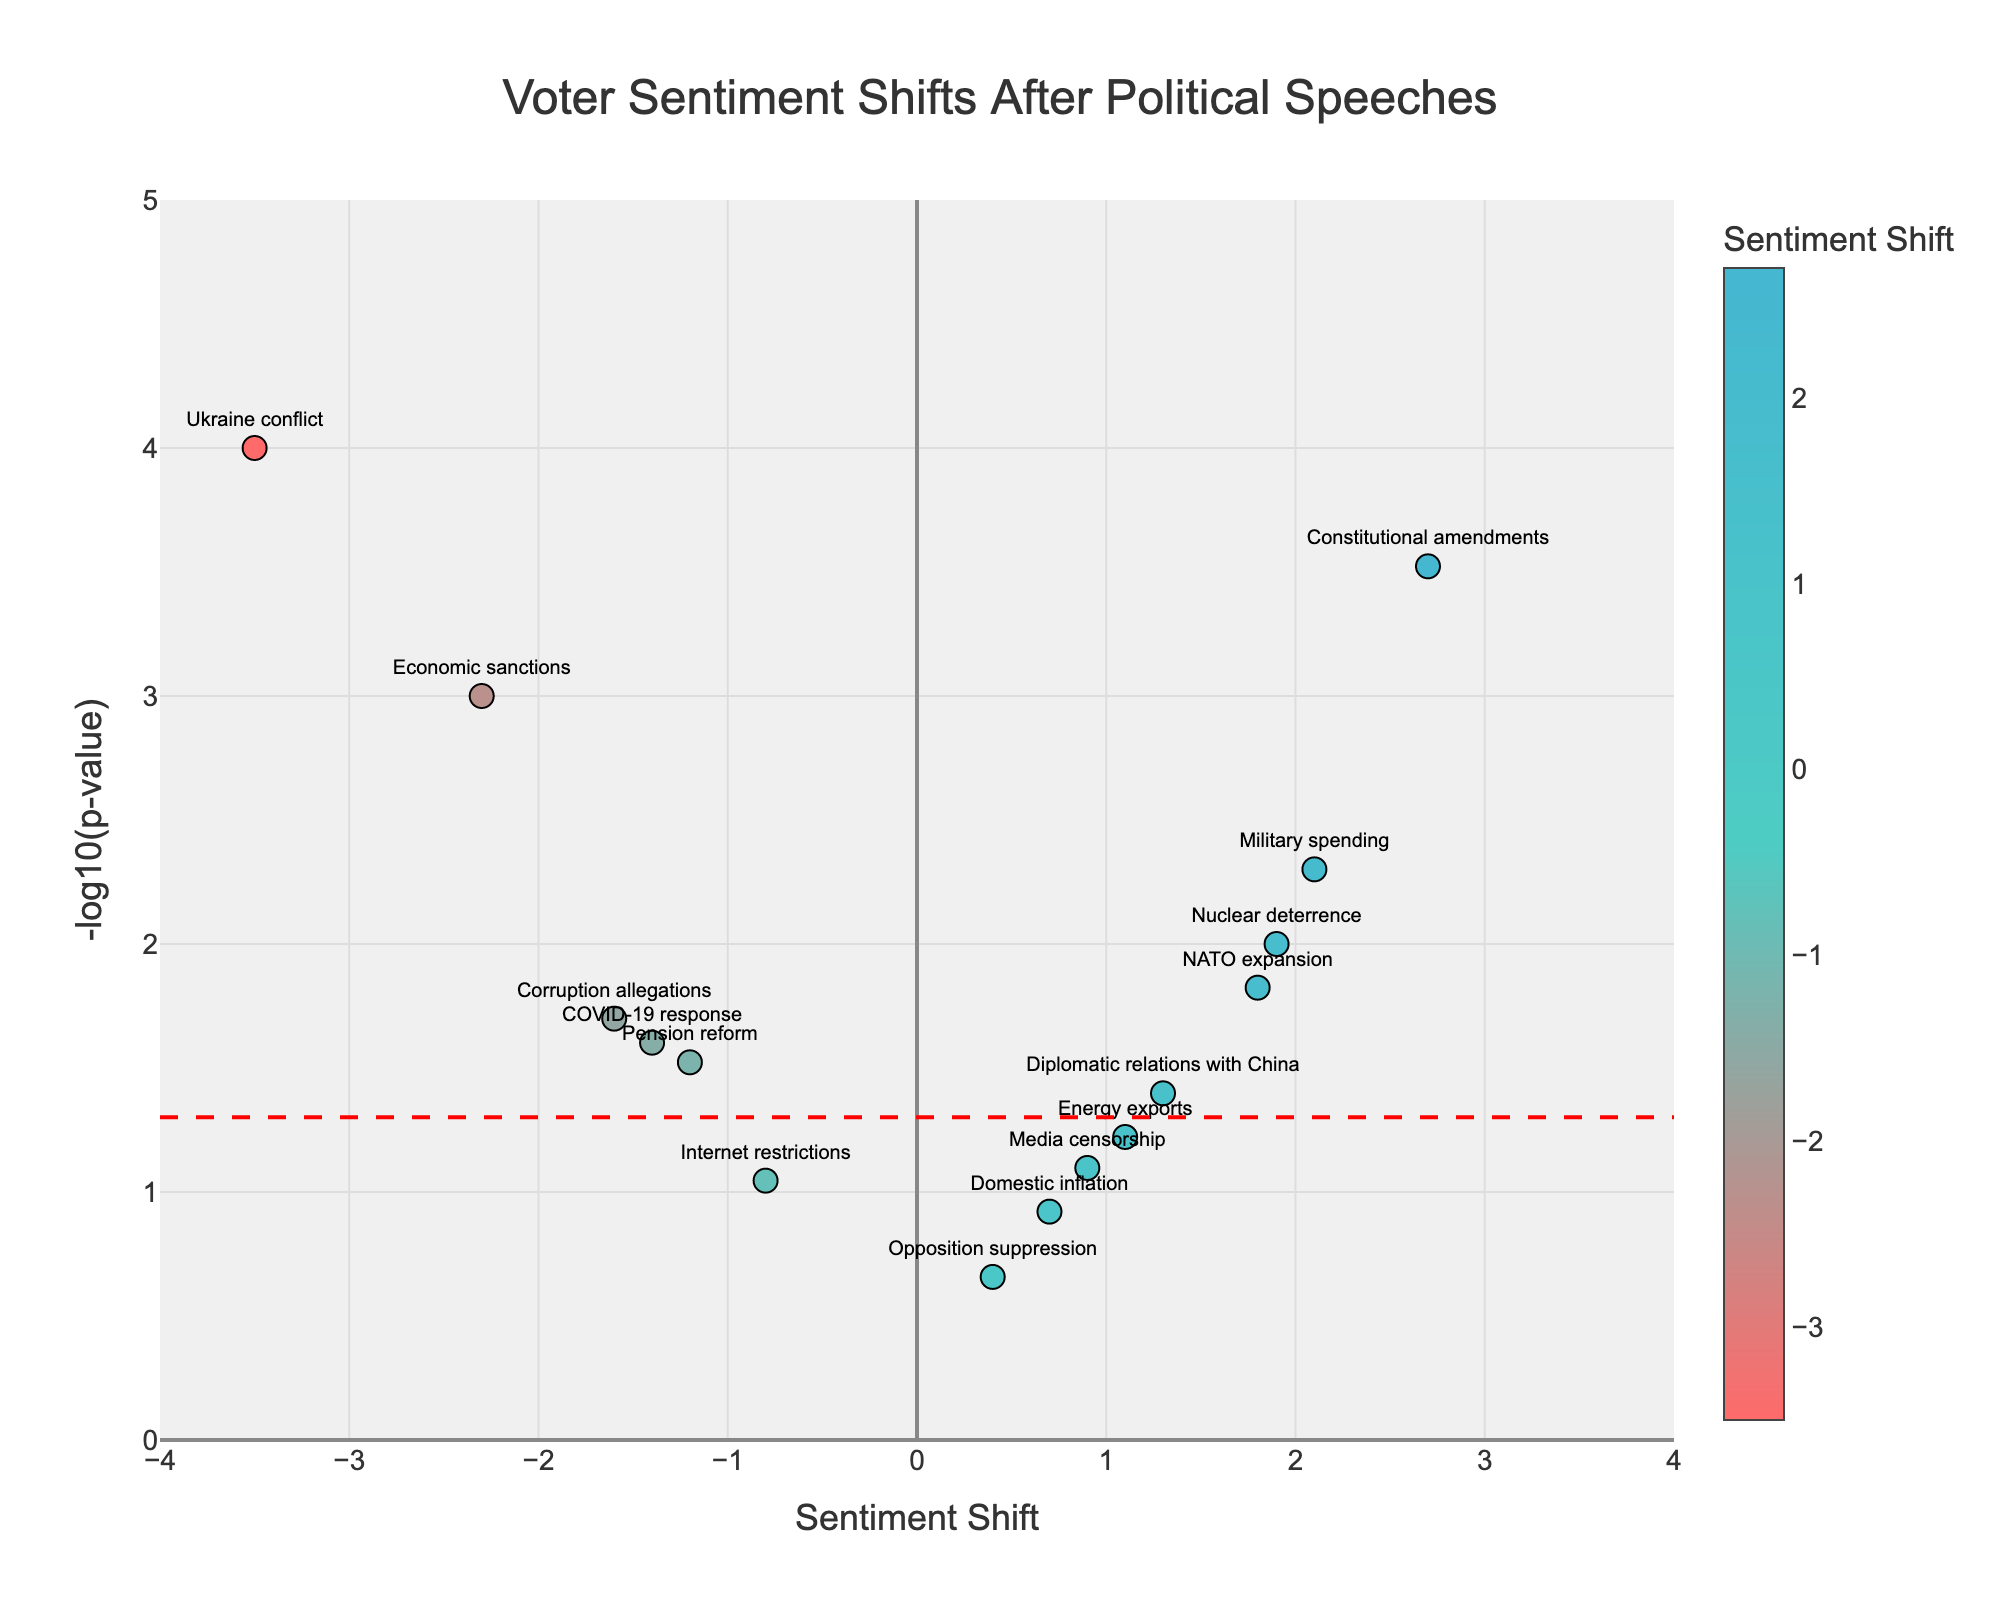How many policy issues showed a positive sentiment shift after the political speeches? Count the data points with a positive sentiment shift value.
Answer: 7 Which policy issue had the most significant negative sentiment shift? Look for the data point with the lowest sentiment shift value.
Answer: Ukraine conflict Are there more policy issues with a positive or negative sentiment shift? Compare the number of data points with positive sentiment shift to those with negative sentiment shift.
Answer: Positive Which policy issues are significantly affected by the speeches (below p-value of 0.05) and have a negative sentiment shift? Filter the data points with p-value < 0.05 and look for negative sentiment shifts.
Answer: Economic sanctions, Ukraine conflict, Pension reform, Corruption allegations, COVID-19 response 